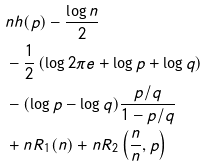<formula> <loc_0><loc_0><loc_500><loc_500>& n h ( p ) - \frac { \log n } { 2 } \\ & - \frac { 1 } { 2 } \left ( \log 2 \pi e + \log p + \log q \right ) \\ & - ( \log p - \log q ) \frac { p / q } { 1 - p / q } \\ & + n R _ { 1 } ( n ) + n R _ { 2 } \left ( \frac { n } { n } , p \right )</formula> 